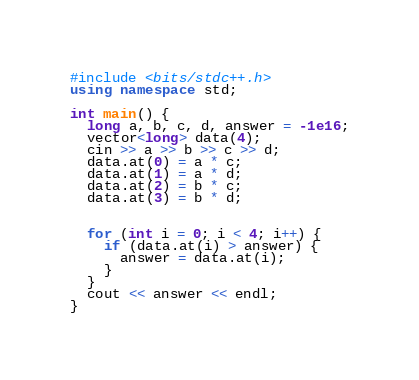Convert code to text. <code><loc_0><loc_0><loc_500><loc_500><_C++_>#include <bits/stdc++.h>
using namespace std;

int main() {
  long a, b, c, d, answer = -1e16;
  vector<long> data(4);
  cin >> a >> b >> c >> d;
  data.at(0) = a * c;
  data.at(1) = a * d;
  data.at(2) = b * c;
  data.at(3) = b * d;


  for (int i = 0; i < 4; i++) {
    if (data.at(i) > answer) {
      answer = data.at(i);
    }
  }
  cout << answer << endl;
}</code> 